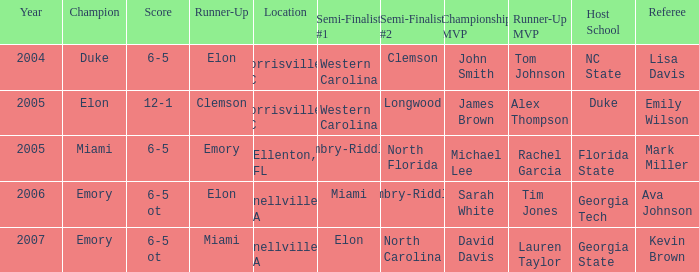Can you give me this table as a dict? {'header': ['Year', 'Champion', 'Score', 'Runner-Up', 'Location', 'Semi-Finalist #1', 'Semi-Finalist #2', 'Championship MVP', 'Runner-Up MVP', 'Host School', 'Referee'], 'rows': [['2004', 'Duke', '6-5', 'Elon', 'Morrisville, NC', 'Western Carolina', 'Clemson', 'John Smith', 'Tom Johnson', 'NC State', 'Lisa Davis'], ['2005', 'Elon', '12-1', 'Clemson', 'Morrisville, NC', 'Western Carolina', 'Longwood', 'James Brown', 'Alex Thompson', 'Duke', 'Emily Wilson'], ['2005', 'Miami', '6-5', 'Emory', 'Ellenton, FL', 'Embry-Riddle', 'North Florida', 'Michael Lee', 'Rachel Garcia', 'Florida State', 'Mark Miller'], ['2006', 'Emory', '6-5 ot', 'Elon', 'Snellville, GA', 'Miami', 'Embry-Riddle', 'Sarah White', 'Tim Jones', 'Georgia Tech', 'Ava Johnson'], ['2007', 'Emory', '6-5 ot', 'Miami', 'Snellville, GA', 'Elon', 'North Carolina', 'David Davis', 'Lauren Taylor', 'Georgia State', 'Kevin Brown']]} Which team was the second semi finalist in 2007? North Carolina. 